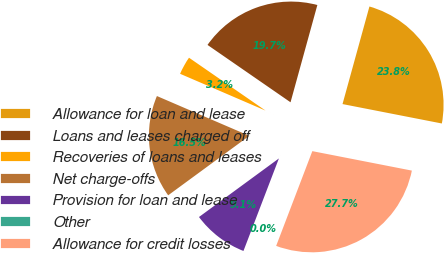Convert chart to OTSL. <chart><loc_0><loc_0><loc_500><loc_500><pie_chart><fcel>Allowance for loan and lease<fcel>Loans and leases charged off<fcel>Recoveries of loans and leases<fcel>Net charge-offs<fcel>Provision for loan and lease<fcel>Other<fcel>Allowance for credit losses<nl><fcel>23.79%<fcel>19.66%<fcel>3.15%<fcel>16.54%<fcel>9.11%<fcel>0.02%<fcel>27.73%<nl></chart> 